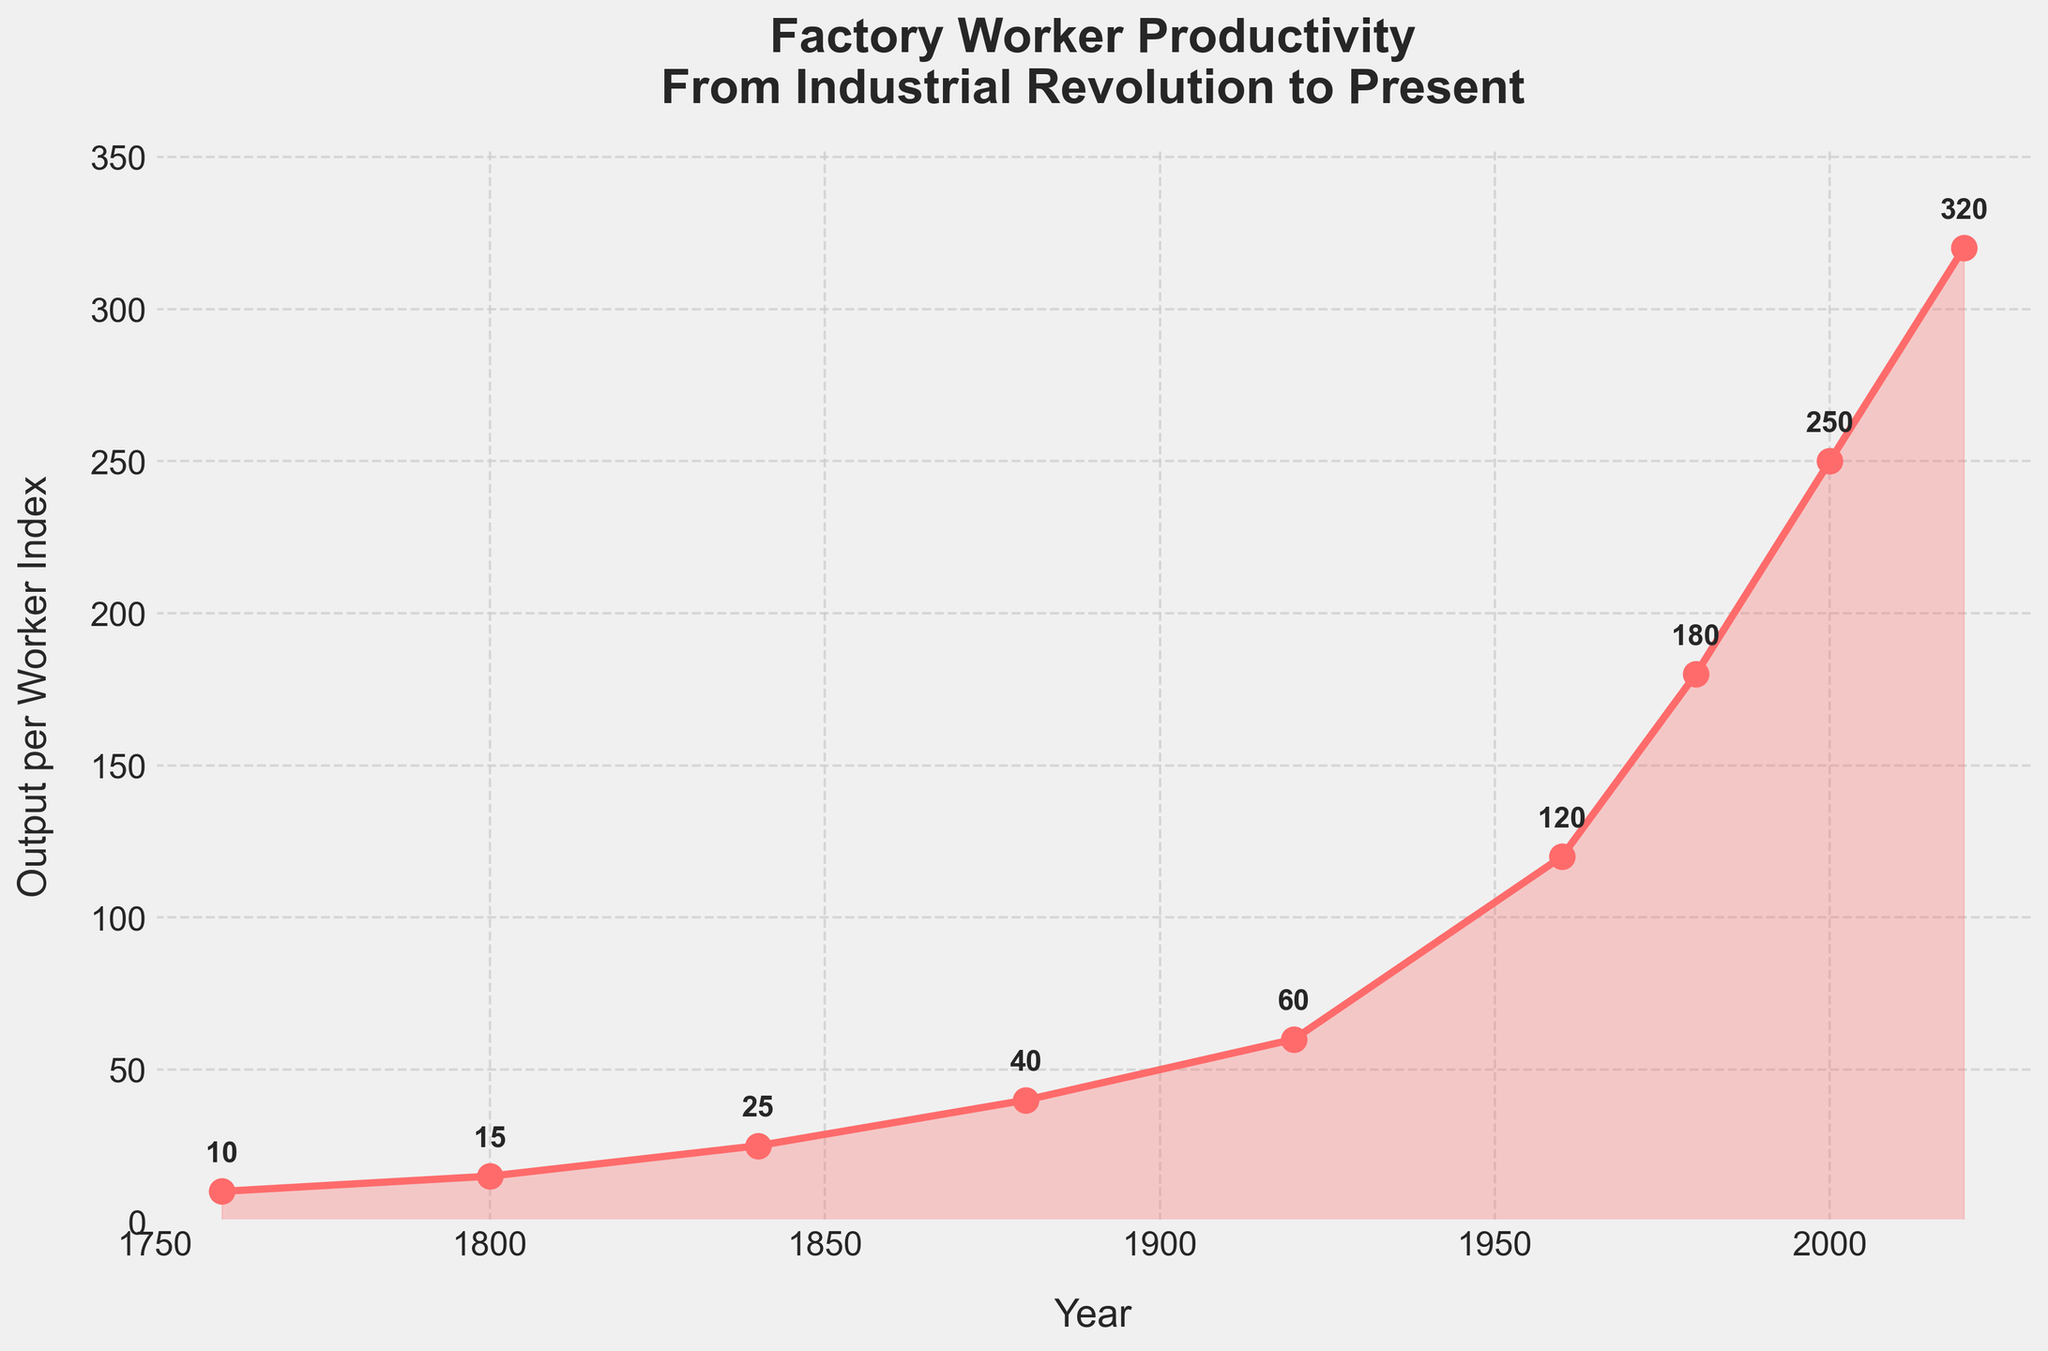What is the general trend of productivity output from 1760 to 2020? The line chart shows a steady increase in productivity output per worker from 1760 to 2020, with several pronounced upward trends occurring in the late 19th to early 20th century and from the mid-20th century onward.
Answer: It increases By how much did the output per worker increase from 1960 to 2000? The output per worker in 1960 was 120, and it increased to 250 in 2000. The difference is calculated as 250 - 120 = 130.
Answer: 130 In which year did the productivity output double relative to its value in 1920? In 1920, the output per worker was 60. Doubling this value equals 120. The chart shows that the output in 1960 was 120, so productivity output doubled by 1960.
Answer: 1960 How does the output per worker in 1880 compare to the output in 2000? In 1880, the output per worker was 40, and in 2000, it was 250. Comparatively, the output in 2000 is significantly higher than in 1880.
Answer: 2000 is higher What is the average productivity output per worker from 1760 to 2020? To find the average, sum the output values and divide by the number of years: (10 + 15 + 25 + 40 + 60 + 120 + 180 + 250 + 320) / 9 = 120.
Answer: 120 Which period saw the most substantial increase in output per worker, 1800 to 1840 or 1980 to 2020? From 1800 to 1840, output increased from 15 to 25, a difference of 10. From 1980 to 2020, output increased from 180 to 320, a difference of 140. Therefore, 1980 to 2020 saw the most substantial increase.
Answer: 1980 to 2020 How much faster did the productivity output grow between 1920 to 1960 compared to 1840 to 1880? From 1920 to 1960, output grew from 60 to 120 (difference of 60). From 1840 to 1880, output grew from 25 to 40 (difference of 15). The growth rate is 60 / 15 = 4 times faster from 1920 to 1960.
Answer: 4 times faster What was the output per worker in the year 1800, and how much does it differ from the output in 2020? The output per worker in 1800 was 15, and in 2020, it was 320. The difference is 320 - 15 = 305.
Answer: 305 